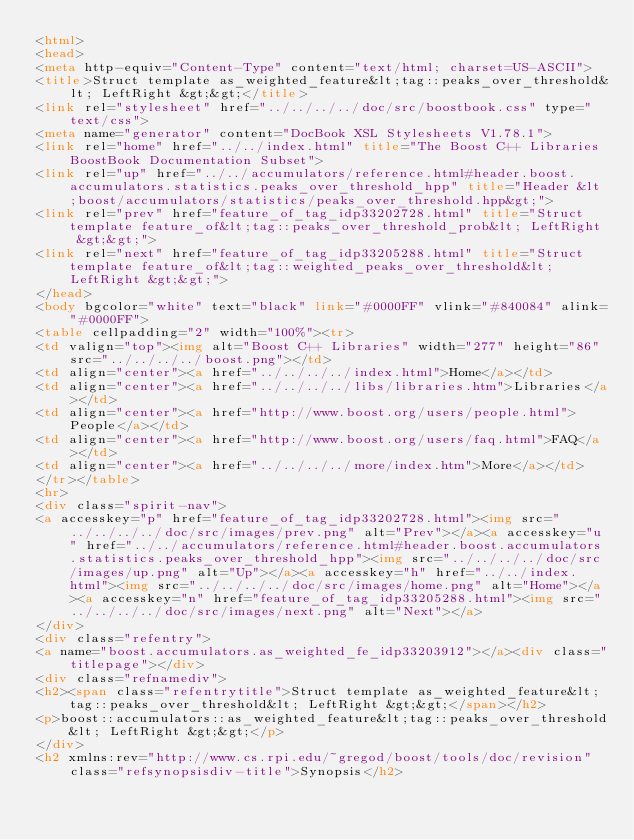Convert code to text. <code><loc_0><loc_0><loc_500><loc_500><_HTML_><html>
<head>
<meta http-equiv="Content-Type" content="text/html; charset=US-ASCII">
<title>Struct template as_weighted_feature&lt;tag::peaks_over_threshold&lt; LeftRight &gt;&gt;</title>
<link rel="stylesheet" href="../../../../doc/src/boostbook.css" type="text/css">
<meta name="generator" content="DocBook XSL Stylesheets V1.78.1">
<link rel="home" href="../../index.html" title="The Boost C++ Libraries BoostBook Documentation Subset">
<link rel="up" href="../../accumulators/reference.html#header.boost.accumulators.statistics.peaks_over_threshold_hpp" title="Header &lt;boost/accumulators/statistics/peaks_over_threshold.hpp&gt;">
<link rel="prev" href="feature_of_tag_idp33202728.html" title="Struct template feature_of&lt;tag::peaks_over_threshold_prob&lt; LeftRight &gt;&gt;">
<link rel="next" href="feature_of_tag_idp33205288.html" title="Struct template feature_of&lt;tag::weighted_peaks_over_threshold&lt; LeftRight &gt;&gt;">
</head>
<body bgcolor="white" text="black" link="#0000FF" vlink="#840084" alink="#0000FF">
<table cellpadding="2" width="100%"><tr>
<td valign="top"><img alt="Boost C++ Libraries" width="277" height="86" src="../../../../boost.png"></td>
<td align="center"><a href="../../../../index.html">Home</a></td>
<td align="center"><a href="../../../../libs/libraries.htm">Libraries</a></td>
<td align="center"><a href="http://www.boost.org/users/people.html">People</a></td>
<td align="center"><a href="http://www.boost.org/users/faq.html">FAQ</a></td>
<td align="center"><a href="../../../../more/index.htm">More</a></td>
</tr></table>
<hr>
<div class="spirit-nav">
<a accesskey="p" href="feature_of_tag_idp33202728.html"><img src="../../../../doc/src/images/prev.png" alt="Prev"></a><a accesskey="u" href="../../accumulators/reference.html#header.boost.accumulators.statistics.peaks_over_threshold_hpp"><img src="../../../../doc/src/images/up.png" alt="Up"></a><a accesskey="h" href="../../index.html"><img src="../../../../doc/src/images/home.png" alt="Home"></a><a accesskey="n" href="feature_of_tag_idp33205288.html"><img src="../../../../doc/src/images/next.png" alt="Next"></a>
</div>
<div class="refentry">
<a name="boost.accumulators.as_weighted_fe_idp33203912"></a><div class="titlepage"></div>
<div class="refnamediv">
<h2><span class="refentrytitle">Struct template as_weighted_feature&lt;tag::peaks_over_threshold&lt; LeftRight &gt;&gt;</span></h2>
<p>boost::accumulators::as_weighted_feature&lt;tag::peaks_over_threshold&lt; LeftRight &gt;&gt;</p>
</div>
<h2 xmlns:rev="http://www.cs.rpi.edu/~gregod/boost/tools/doc/revision" class="refsynopsisdiv-title">Synopsis</h2></code> 